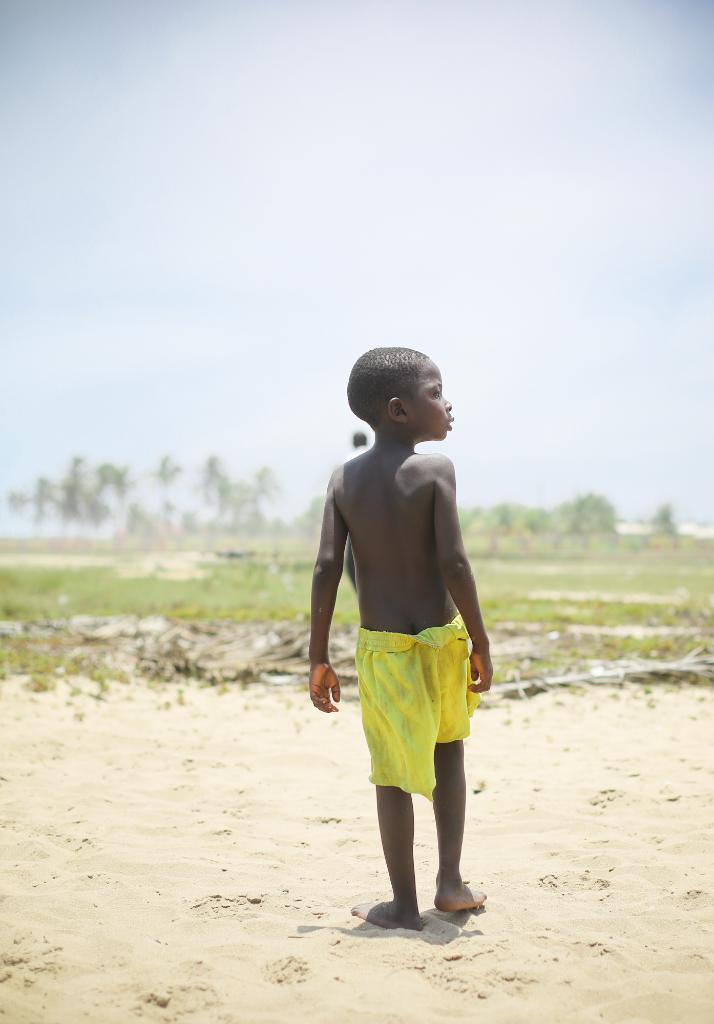What is the main subject of the image? There is a kid standing in the image. What can be seen in the background of the image? There are trees and the sky visible in the background of the image. What type of animal is attempting to use a hammer in the image? There is no animal or hammer present in the image. 